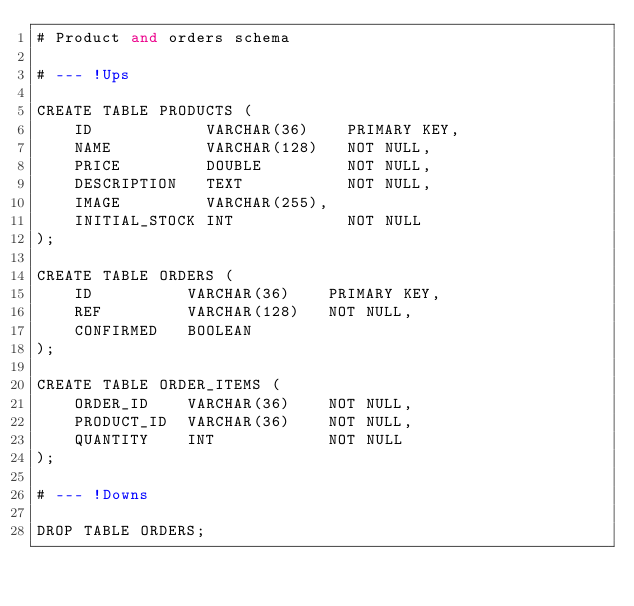<code> <loc_0><loc_0><loc_500><loc_500><_SQL_># Product and orders schema

# --- !Ups

CREATE TABLE PRODUCTS (
    ID            VARCHAR(36)    PRIMARY KEY,
    NAME          VARCHAR(128)   NOT NULL,
    PRICE         DOUBLE         NOT NULL,
    DESCRIPTION   TEXT           NOT NULL,
    IMAGE         VARCHAR(255),
    INITIAL_STOCK INT            NOT NULL
);

CREATE TABLE ORDERS (
    ID          VARCHAR(36)    PRIMARY KEY,
    REF         VARCHAR(128)   NOT NULL,
    CONFIRMED   BOOLEAN
);

CREATE TABLE ORDER_ITEMS (
    ORDER_ID    VARCHAR(36)    NOT NULL,
    PRODUCT_ID  VARCHAR(36)    NOT NULL,
    QUANTITY    INT            NOT NULL
);

# --- !Downs

DROP TABLE ORDERS;</code> 